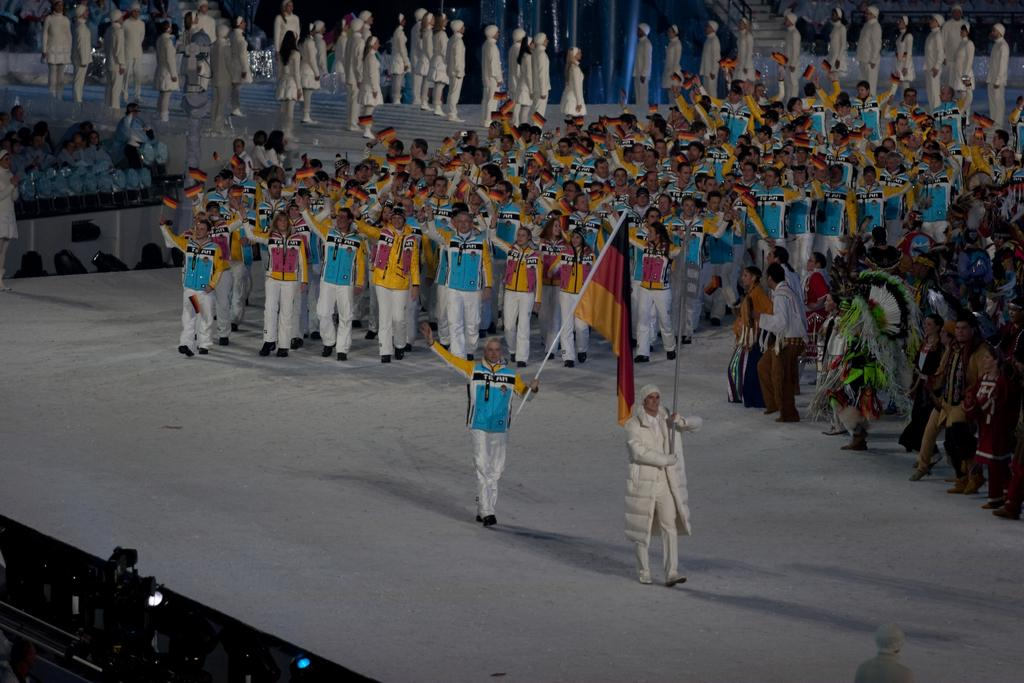What are the people in the image doing? The people in the image are performing a march. What is located at the bottom of the image? There is a dais at the bottom of the image. What are the people holding while marching? The people are holding rods. What can be seen in the background of the image? In the background, there are many people wearing white dresses. What type of loaf can be seen in the image? There is no loaf present in the image. What is the source of humor in the image? The image does not appear to be intended to be humorous, so there is no source of humor. 